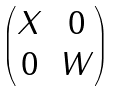<formula> <loc_0><loc_0><loc_500><loc_500>\begin{pmatrix} X & 0 \\ 0 & W \end{pmatrix}</formula> 